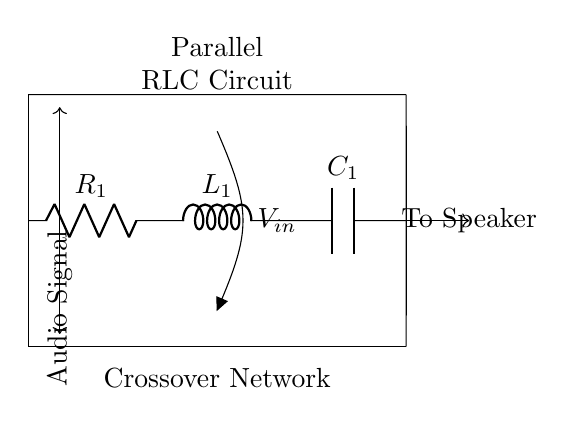What components are present in this circuit? The circuit contains a resistor, inductor, and capacitor, which are labeled as R1, L1, and C1, respectively. These components are visible in the diagram.
Answer: Resistor, Inductor, Capacitor What is the input voltage represented in this circuit? The input voltage is labeled as V_in and is connected at the top of the circuit, indicating the voltage applied across the parallel components.
Answer: V_in What is the function of this parallel RLC circuit? This circuit serves as a crossover network, which divides the audio signal into different frequency ranges, allowing specific frequencies to be sent to designated speakers.
Answer: Crossover network Which component would primarily filter high frequencies? The capacitor (C1) typically blocks low frequencies and allows high frequencies to pass, making it the primary filter for high frequencies in this circuit setup.
Answer: Capacitor How are the components arranged in this circuit? The components are arranged in parallel, as indicated by the connections on the same horizontal level between the input voltage and the output to the speaker, allowing all components to share the same voltage.
Answer: Parallel arrangement What does the audio signal represent in this circuit? The audio signal represents the input signal that is processed by the crossover network, which is necessary for separating different frequency components before sending them to the speakers.
Answer: Audio signal 